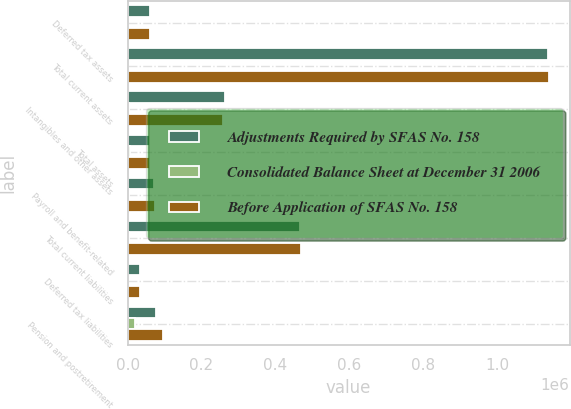<chart> <loc_0><loc_0><loc_500><loc_500><stacked_bar_chart><ecel><fcel>Deferred tax assets<fcel>Total current assets<fcel>Intangibles and other assets<fcel>Total assets<fcel>Payroll and benefit-related<fcel>Total current liabilities<fcel>Deferred tax liabilities<fcel>Pension and postretirement<nl><fcel>Adjustments Required by SFAS No. 158<fcel>59446<fcel>1.13801e+06<fcel>262991<fcel>60204.5<fcel>70413<fcel>466781<fcel>34774<fcel>77269<nl><fcel>Consolidated Balance Sheet at December 31 2006<fcel>1517<fcel>1517<fcel>3762<fcel>5322<fcel>3994<fcel>3994<fcel>1430<fcel>19922<nl><fcel>Before Application of SFAS No. 158<fcel>60963<fcel>1.13953e+06<fcel>259229<fcel>60204.5<fcel>74407<fcel>470775<fcel>33344<fcel>97191<nl></chart> 